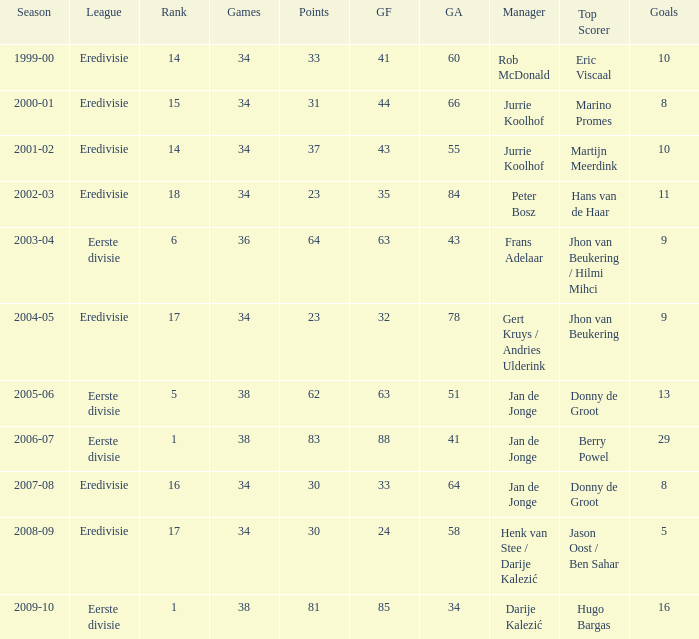How many goals were scored in the 2005-06 season? 13.0. 